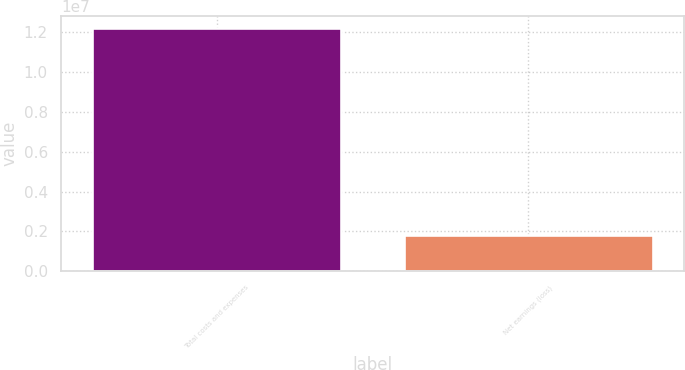Convert chart. <chart><loc_0><loc_0><loc_500><loc_500><bar_chart><fcel>Total costs and expenses<fcel>Net earnings (loss)<nl><fcel>1.21874e+07<fcel>1.83751e+06<nl></chart> 